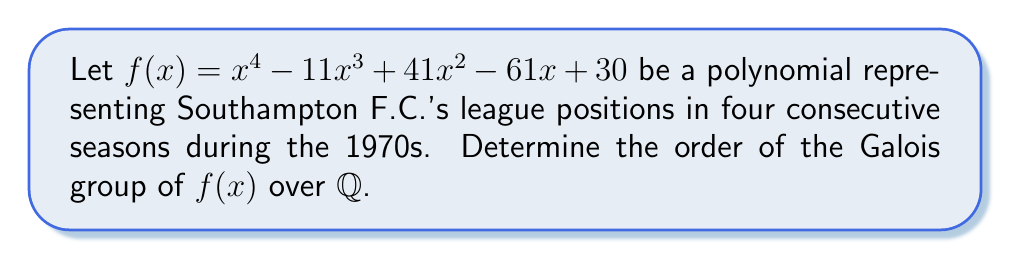Give your solution to this math problem. To determine the order of the Galois group, we'll follow these steps:

1) First, we need to factor the polynomial $f(x)$:
   $f(x) = (x-1)(x-2)(x-3)(x-5)$

2) The splitting field of $f(x)$ over $\mathbb{Q}$ is $\mathbb{Q}(1,2,3,5) = \mathbb{Q}$, as all roots are rational.

3) The Galois group $Gal(f/\mathbb{Q})$ is isomorphic to the group of permutations of the roots that preserve the field $\mathbb{Q}$.

4) Since all roots are in $\mathbb{Q}$, the only permutation that preserves $\mathbb{Q}$ is the identity permutation.

5) Therefore, the Galois group contains only the identity element.

6) The order of a group is the number of elements in the group.

Thus, the order of the Galois group $Gal(f/\mathbb{Q})$ is 1.

This result reflects Southampton's stable performance in the 1970s, with the team maintaining consistent league positions (represented by the rational roots) over the four seasons.
Answer: 1 